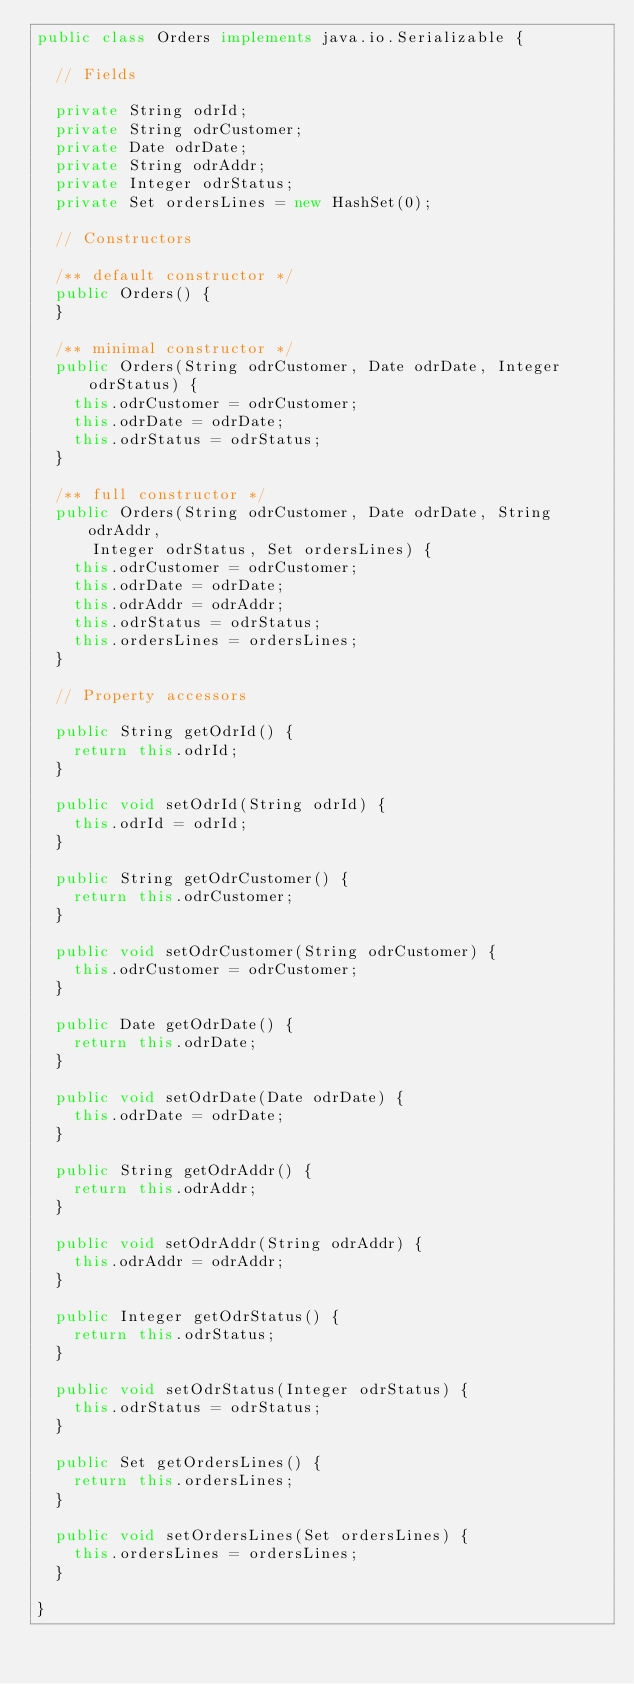Convert code to text. <code><loc_0><loc_0><loc_500><loc_500><_Java_>public class Orders implements java.io.Serializable {

	// Fields

	private String odrId;
	private String odrCustomer;
	private Date odrDate;
	private String odrAddr;
	private Integer odrStatus;
	private Set ordersLines = new HashSet(0);

	// Constructors

	/** default constructor */
	public Orders() {
	}

	/** minimal constructor */
	public Orders(String odrCustomer, Date odrDate, Integer odrStatus) {
		this.odrCustomer = odrCustomer;
		this.odrDate = odrDate;
		this.odrStatus = odrStatus;
	}

	/** full constructor */
	public Orders(String odrCustomer, Date odrDate, String odrAddr,
			Integer odrStatus, Set ordersLines) {
		this.odrCustomer = odrCustomer;
		this.odrDate = odrDate;
		this.odrAddr = odrAddr;
		this.odrStatus = odrStatus;
		this.ordersLines = ordersLines;
	}

	// Property accessors

	public String getOdrId() {
		return this.odrId;
	}

	public void setOdrId(String odrId) {
		this.odrId = odrId;
	}

	public String getOdrCustomer() {
		return this.odrCustomer;
	}

	public void setOdrCustomer(String odrCustomer) {
		this.odrCustomer = odrCustomer;
	}

	public Date getOdrDate() {
		return this.odrDate;
	}

	public void setOdrDate(Date odrDate) {
		this.odrDate = odrDate;
	}

	public String getOdrAddr() {
		return this.odrAddr;
	}

	public void setOdrAddr(String odrAddr) {
		this.odrAddr = odrAddr;
	}

	public Integer getOdrStatus() {
		return this.odrStatus;
	}

	public void setOdrStatus(Integer odrStatus) {
		this.odrStatus = odrStatus;
	}

	public Set getOrdersLines() {
		return this.ordersLines;
	}

	public void setOrdersLines(Set ordersLines) {
		this.ordersLines = ordersLines;
	}

}</code> 